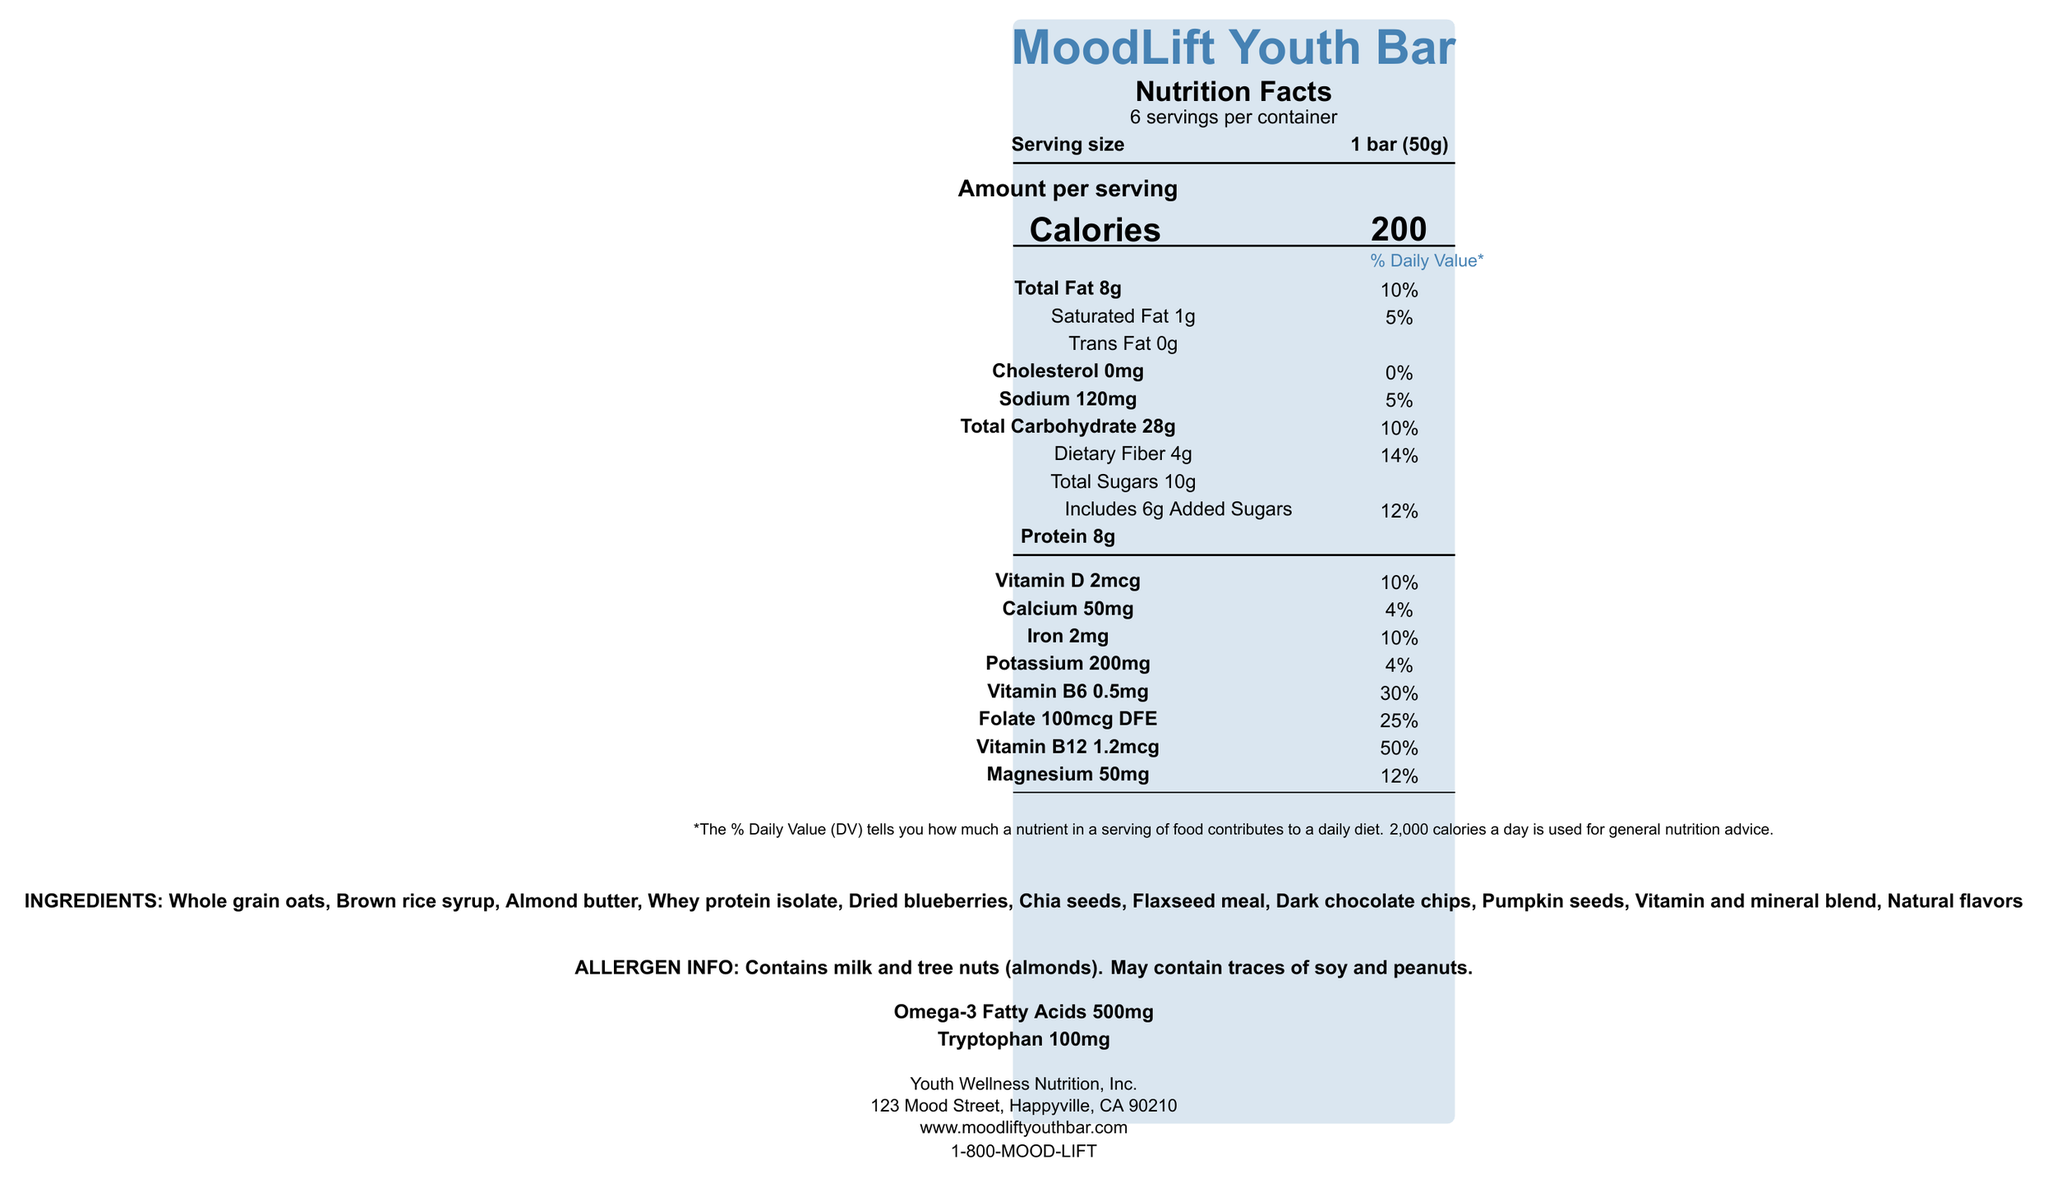What is the serving size of the MoodLift Youth Bar? The serving size is clearly stated as "1 bar (50g)".
Answer: 1 bar (50g) What is the total fat content per serving? The Nutrition Facts label lists the total fat content as "8g" per serving.
Answer: 8g How much protein does each serving contain? The protein content per serving is mentioned as "8g" on the label.
Answer: 8g What is the daily value percentage of Vitamin B6 in a MoodLift Youth Bar? The label states that Vitamin B6 provides 30% of the daily value.
Answer: 30% What allergens are present in the MoodLift Youth Bar? The allergen information section indicates the presence of milk and tree nuts (almonds) and potential traces of soy and peanuts.
Answer: Milk and tree nuts (almonds), may contain traces of soy and peanuts. Which ingredients contribute to the high fiber content of the bar? A. Dark chocolate chips B. Brown rice syrup C. Whole grain oats D. Almond butter Whole grain oats are a known source of dietary fiber, contributing to the high fiber content in the bar.
Answer: C What is the percentage of daily value for iron in one serving? A. 4% B. 10% C. 15% D. 25% The label mentions that iron contributes 10% of the daily value per serving.
Answer: B Does the MoodLift Youth Bar contain any trans fat? The Nutrition Facts label states "Trans Fat 0g" indicating there is no trans fat in the bar.
Answer: No Is the MoodLift Youth Bar free from artificial colors, flavors, and preservatives? One of the product claims states that it contains "No artificial colors, flavors, or preservatives".
Answer: Yes Summarize the main idea of the MoodLift Youth Bar Nutrition Facts Label. The document contains detailed nutritional information about the MoodLift Youth Bar, including serving size, nutrients, ingredient list, allergen information, and special claims about the bar's mental health benefits.
Answer: The MoodLift Youth Bar is a nutritional snack designed to support mood and mental well-being, providing beneficial nutrients such as omega-3 fatty acids, B-vitamins, tryptophan, and fiber. It's formulated for youth, especially those with depression, and it includes clear allergen information. What is the address of the manufacturer of the MoodLift Youth Bar? The label provides the manufacturer's address as "123 Mood Street, Happyville, CA 90210".
Answer: 123 Mood Street, Happyville, CA 90210 How many servings are there in each container of MoodLift Youth Bars? The label clearly states "6 servings per container".
Answer: 6 How much calcium is in one serving of the MoodLift Youth Bar? Under the nutrition facts, the calcium content is listed as "50mg".
Answer: 50mg What is the company's customer service contact number? The customer service contact number provided is "1-800-MOOD-LIFT".
Answer: 1-800-MOOD-LIFT Which ingredient is likely included for its omega-3 fatty acid content? Chia seeds are known to be rich in omega-3 fatty acids and are listed as one of the ingredients.
Answer: Chia seeds What is the storage instruction for the MoodLift Youth Bar after opening? The storage instructions advise consuming within 14 days of opening.
Answer: Consume within 14 days Is there information about the bar improving cognitive performance? The label mentions mood and mental well-being but doesn't specify cognitive performance improvement.
Answer: Not enough information 